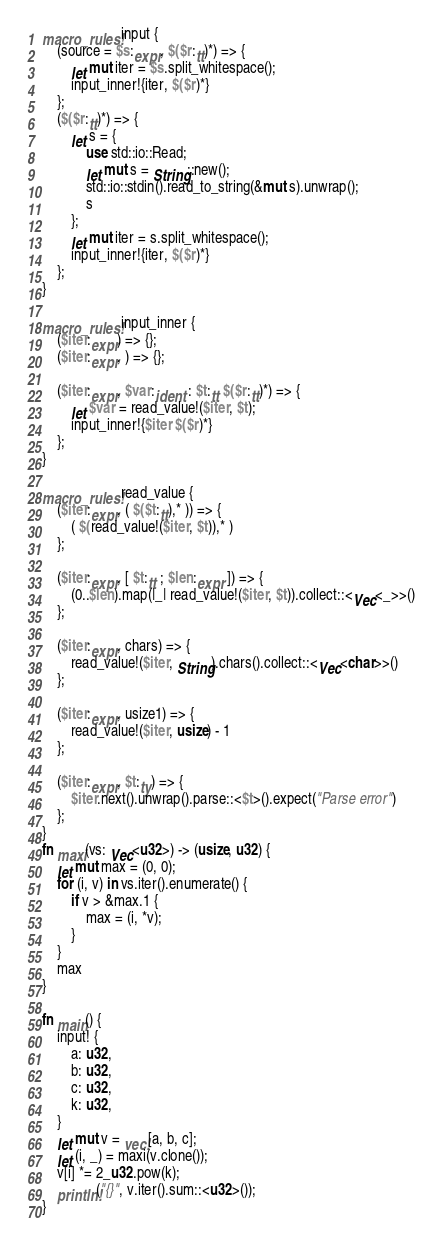<code> <loc_0><loc_0><loc_500><loc_500><_Rust_>macro_rules! input {
    (source = $s:expr, $($r:tt)*) => {
        let mut iter = $s.split_whitespace();
        input_inner!{iter, $($r)*}
    };
    ($($r:tt)*) => {
        let s = {
            use std::io::Read;
            let mut s = String::new();
            std::io::stdin().read_to_string(&mut s).unwrap();
            s
        };
        let mut iter = s.split_whitespace();
        input_inner!{iter, $($r)*}
    };
}

macro_rules! input_inner {
    ($iter:expr) => {};
    ($iter:expr, ) => {};

    ($iter:expr, $var:ident : $t:tt $($r:tt)*) => {
        let $var = read_value!($iter, $t);
        input_inner!{$iter $($r)*}
    };
}

macro_rules! read_value {
    ($iter:expr, ( $($t:tt),* )) => {
        ( $(read_value!($iter, $t)),* )
    };

    ($iter:expr, [ $t:tt ; $len:expr ]) => {
        (0..$len).map(|_| read_value!($iter, $t)).collect::<Vec<_>>()
    };

    ($iter:expr, chars) => {
        read_value!($iter, String).chars().collect::<Vec<char>>()
    };

    ($iter:expr, usize1) => {
        read_value!($iter, usize) - 1
    };

    ($iter:expr, $t:ty) => {
        $iter.next().unwrap().parse::<$t>().expect("Parse error")
    };
}
fn maxi(vs: Vec<u32>) -> (usize, u32) {
    let mut max = (0, 0);
    for (i, v) in vs.iter().enumerate() {
        if v > &max.1 {
            max = (i, *v);
        }
    }
    max
}

fn main() {
    input! {
        a: u32,
        b: u32,
        c: u32,
        k: u32,
    }
    let mut v = vec![a, b, c];
    let (i, _) = maxi(v.clone());
    v[i] *= 2_u32.pow(k);
    println!("{}", v.iter().sum::<u32>());
}</code> 